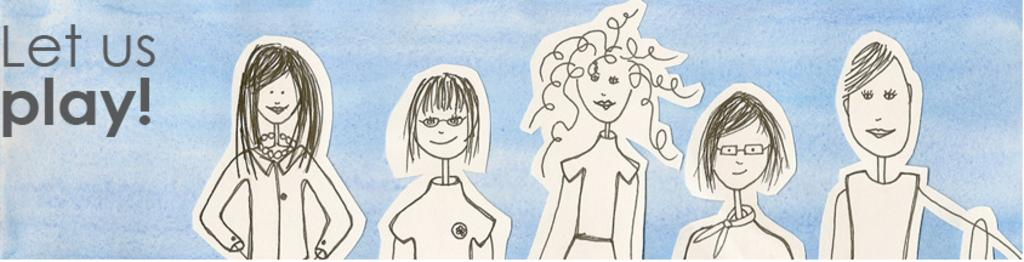What is there is a poster in the center of the image, what is depicted on it? There is a poster in the center of the image, and it has drawings on it. What message is conveyed by the poster? The text "Let Us Play" is written on the poster. Can you describe the drawings on the poster? Unfortunately, the details of the drawings on the poster are not mentioned in the facts provided. How many eggs are present in the image? There is no mention of eggs in the image, so we cannot determine their presence or quantity. 